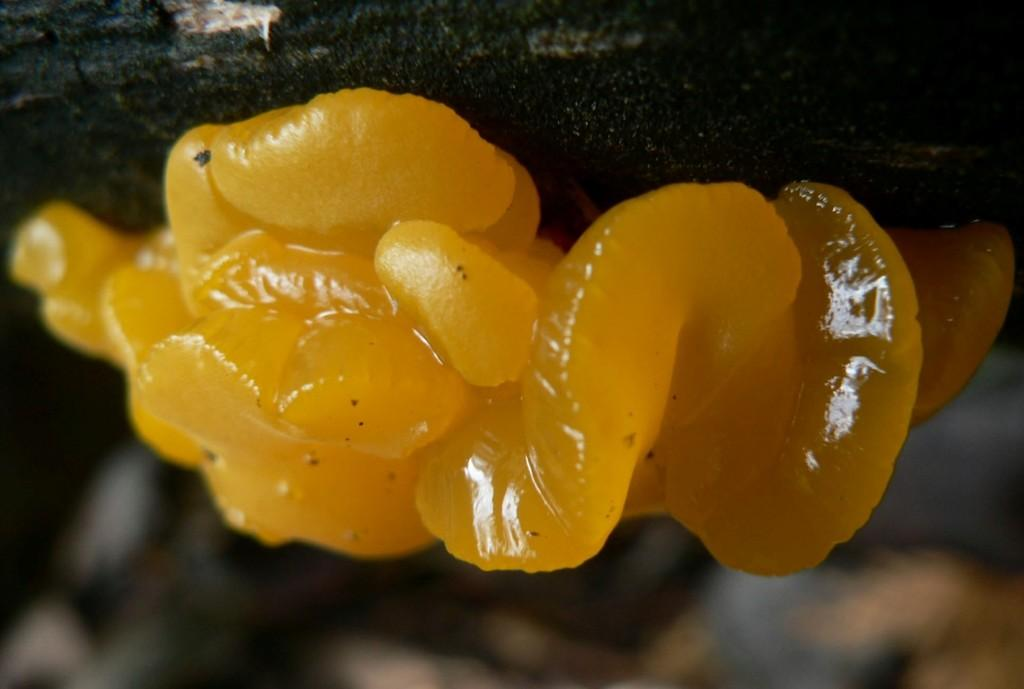What is the main subject of the image? The main subject of the image is a wood ear. What color is the wood ear in the image? The wood ear is in yellow color. Can you describe the background of the image? The background of the image is blurred. How many owls can be seen in the image? There are no owls present in the image; it features a yellow wood ear. What type of drink is being served in the image? There is no drink present in the image, so it cannot be determined what type of drink might be served. 